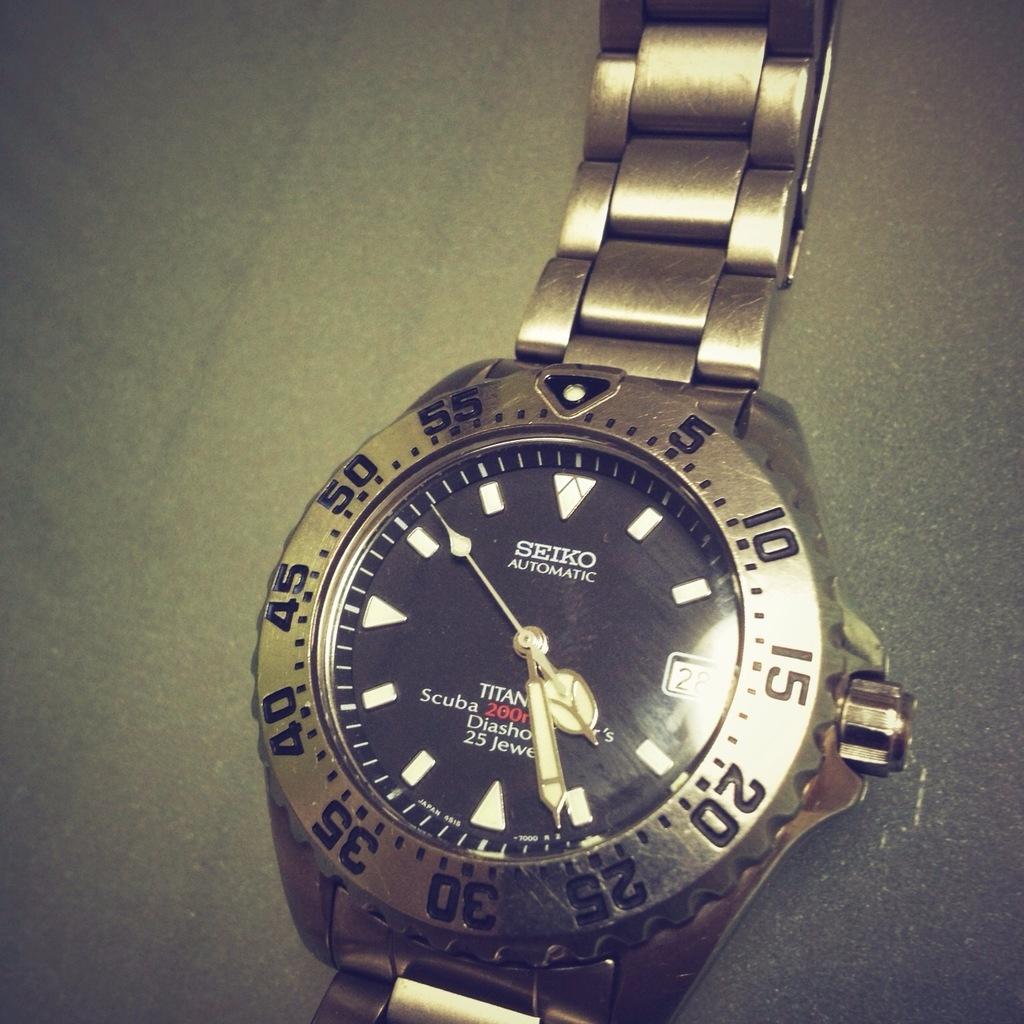What brand is the watch?
Keep it short and to the point. Seiko. What number is in red?
Ensure brevity in your answer.  200. 